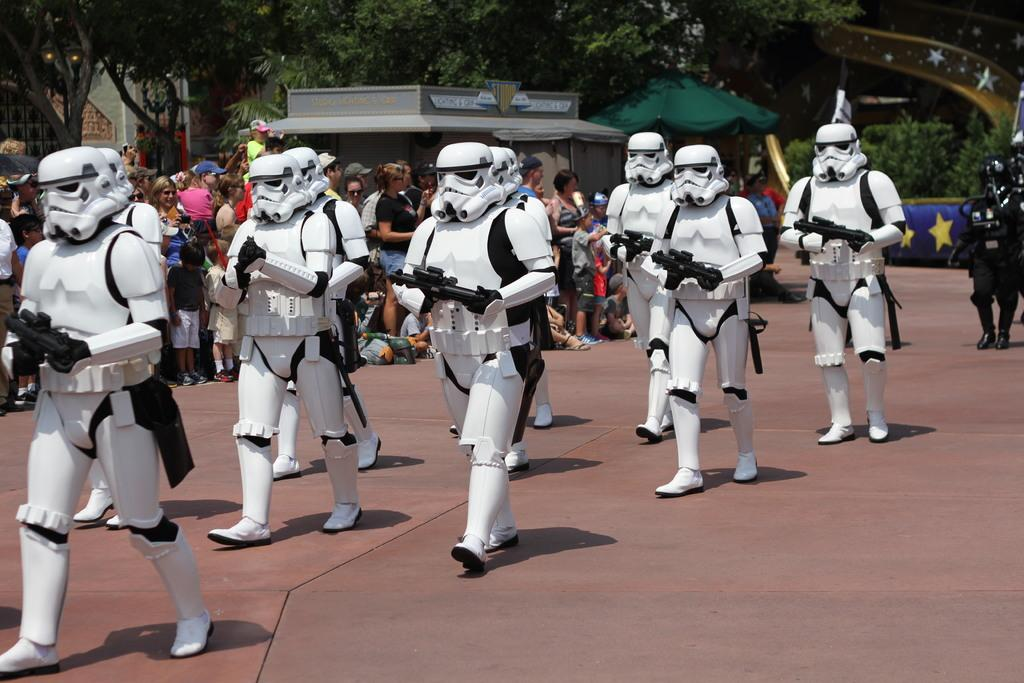What is happening in the image involving the group of people? The people in the image are holding guns. What are the people wearing in the image? The people are wearing costumes. What can be seen in the background of the image? There is a crowd of people, a house, tents, and trees in the background of the image. What type of argument can be heard between the people in the image? There is no indication of an argument in the image; the people are holding guns and wearing costumes. What smell is present in the image? There is no information about smells in the image. 